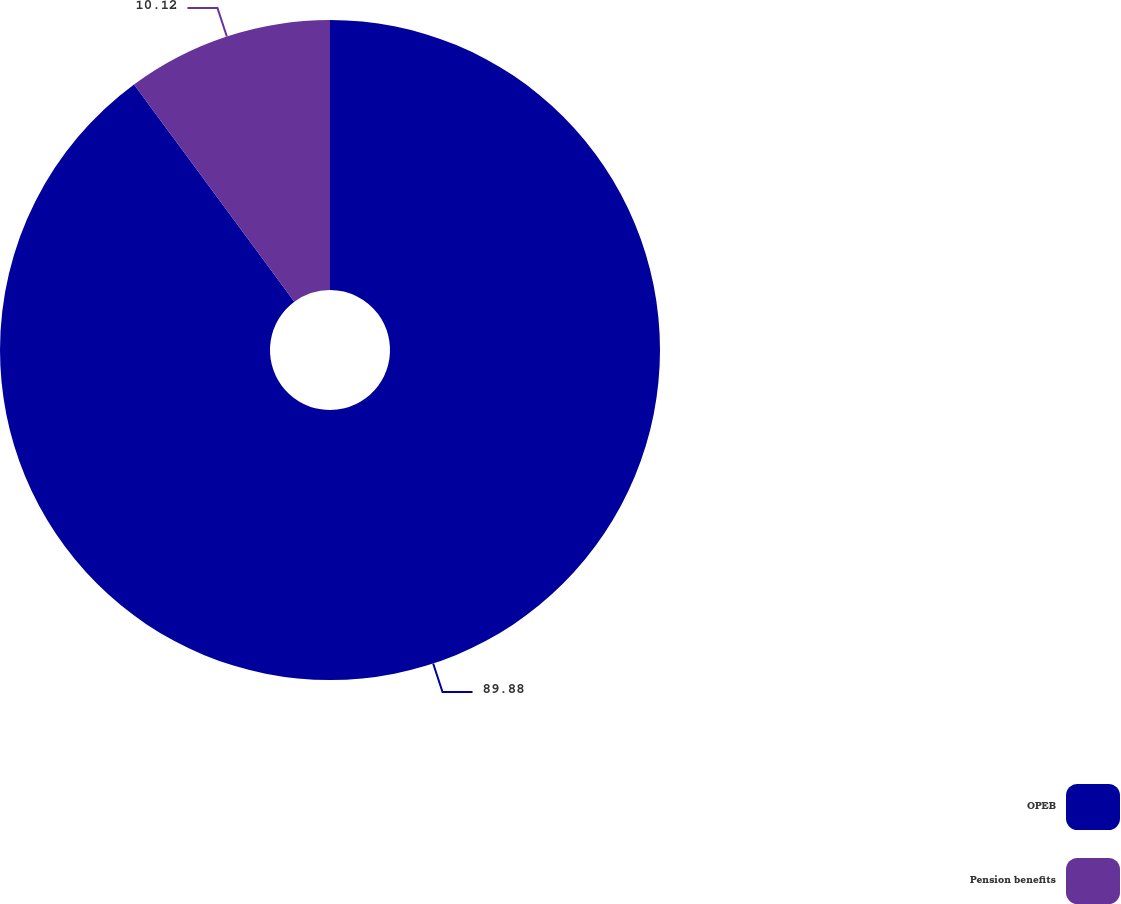Convert chart to OTSL. <chart><loc_0><loc_0><loc_500><loc_500><pie_chart><fcel>OPEB<fcel>Pension benefits<nl><fcel>89.88%<fcel>10.12%<nl></chart> 